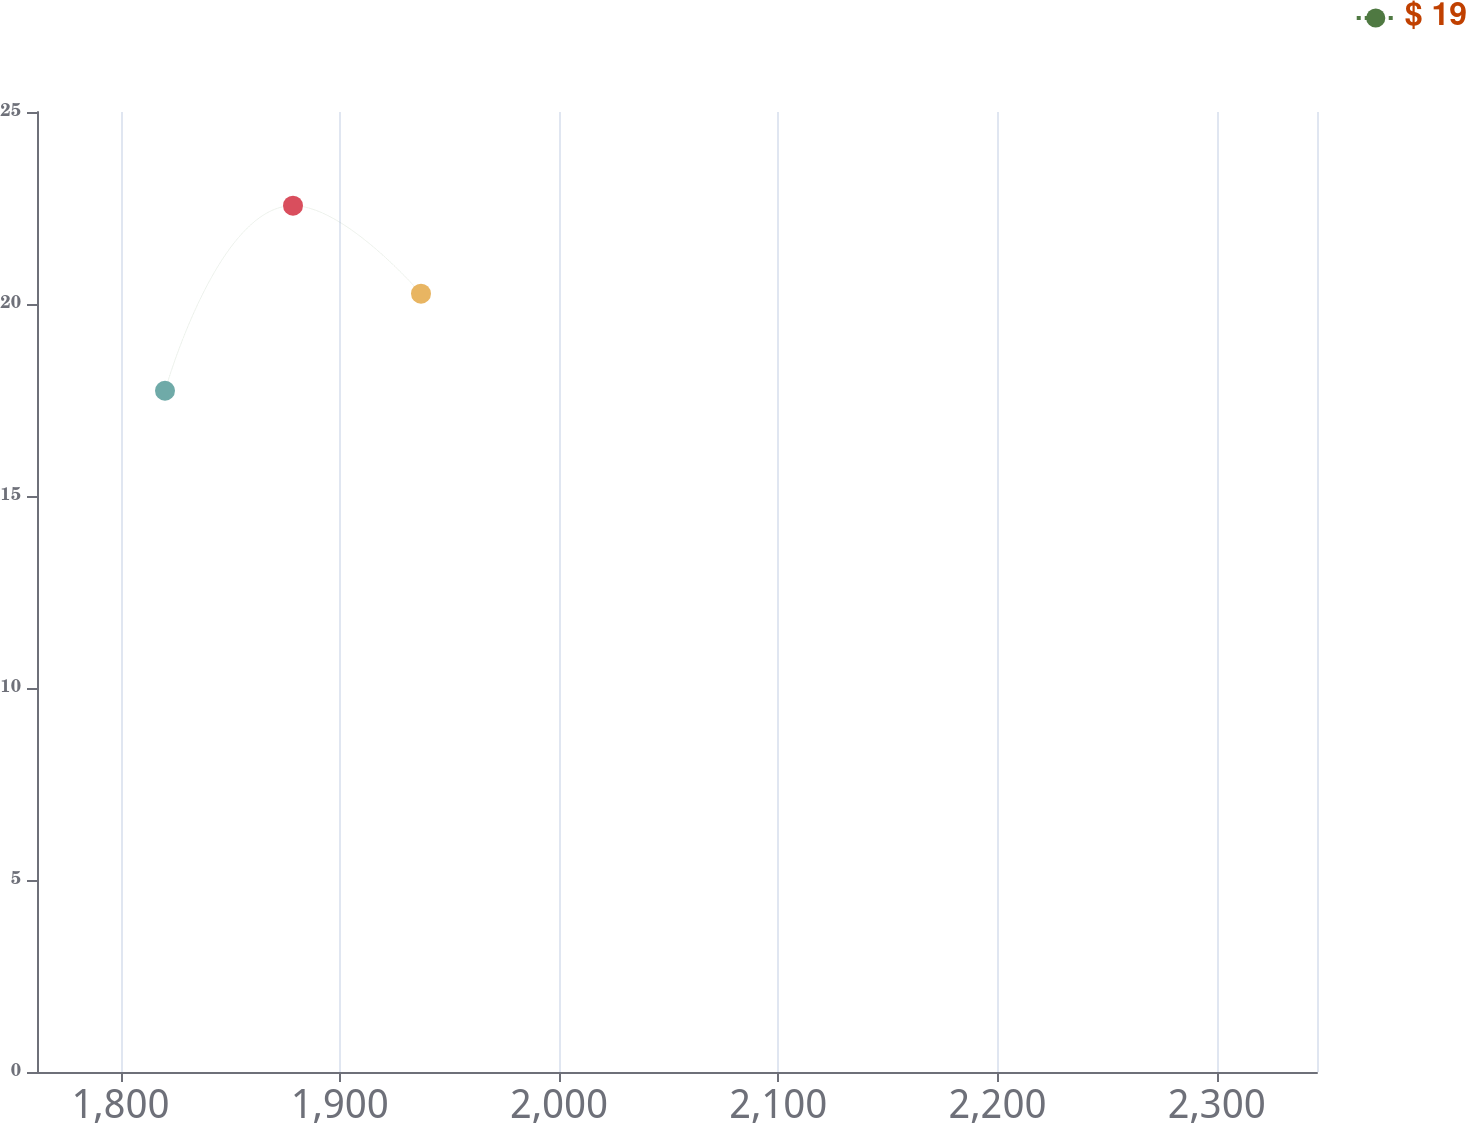Convert chart. <chart><loc_0><loc_0><loc_500><loc_500><line_chart><ecel><fcel>$ 19<nl><fcel>1820.27<fcel>17.74<nl><fcel>1878.65<fcel>22.56<nl><fcel>1937.03<fcel>20.27<nl><fcel>2404.08<fcel>17.2<nl></chart> 